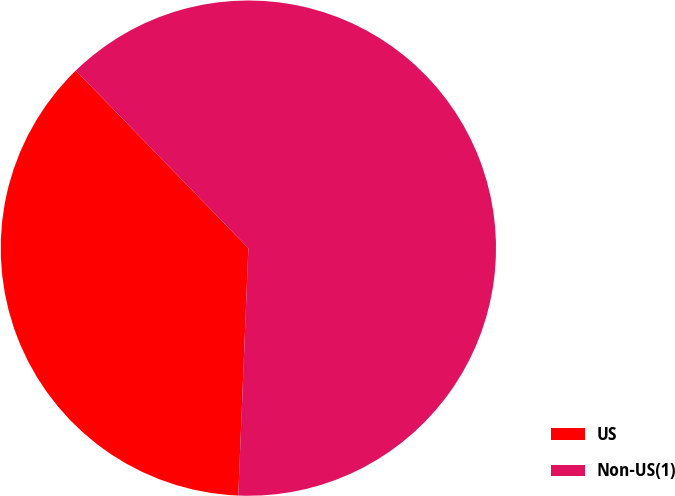Convert chart. <chart><loc_0><loc_0><loc_500><loc_500><pie_chart><fcel>US<fcel>Non-US(1)<nl><fcel>37.08%<fcel>62.92%<nl></chart> 